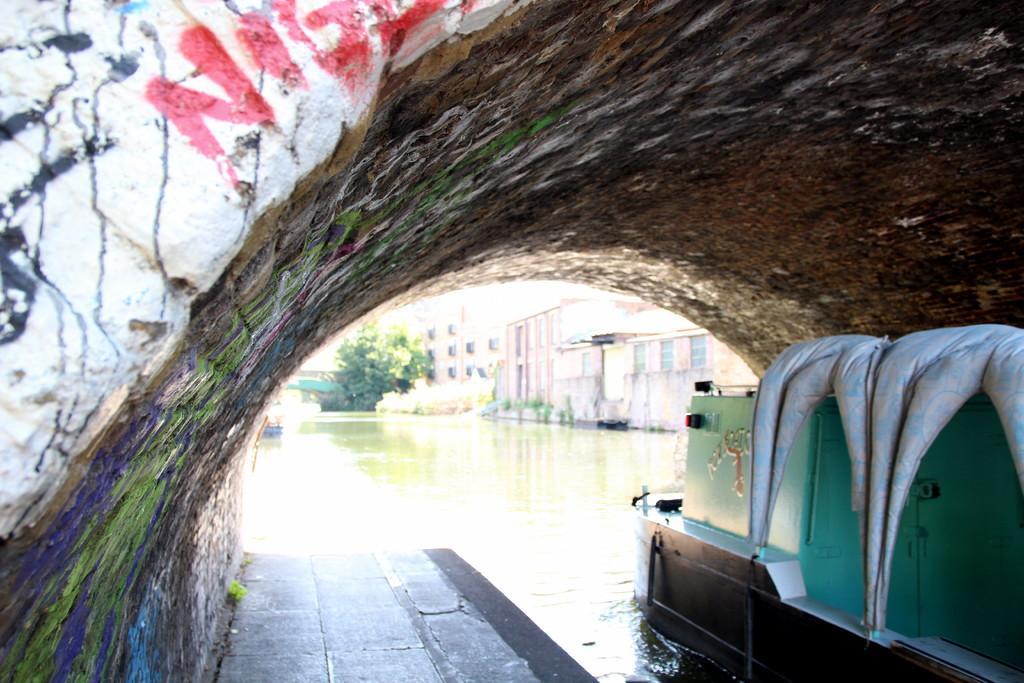Please provide a concise description of this image. In this image there is a tunnel and we can see a boat on the water. In the background there are buildings and trees. 